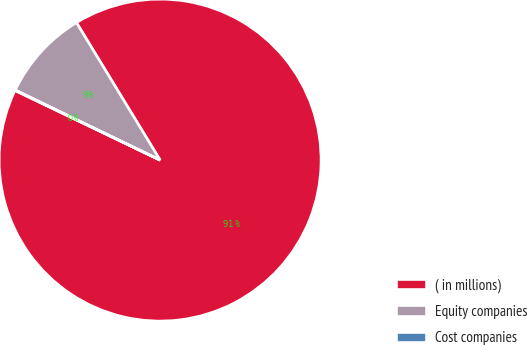Convert chart. <chart><loc_0><loc_0><loc_500><loc_500><pie_chart><fcel>( in millions)<fcel>Equity companies<fcel>Cost companies<nl><fcel>90.82%<fcel>9.13%<fcel>0.05%<nl></chart> 